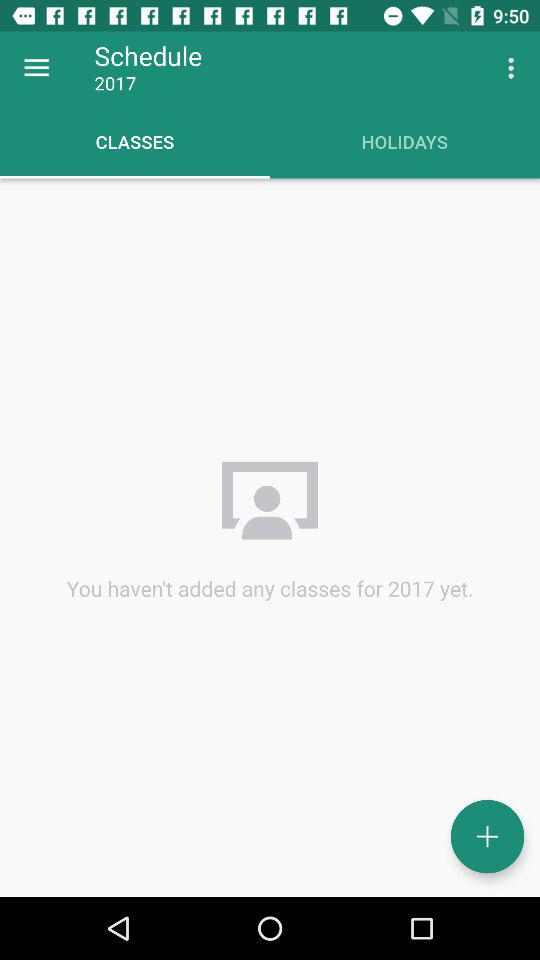How many classes have you added to your schedule?
Answer the question using a single word or phrase. 0 